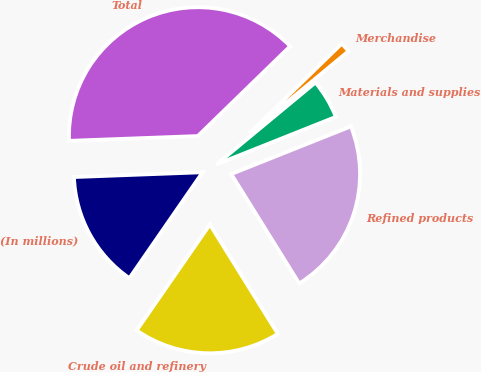<chart> <loc_0><loc_0><loc_500><loc_500><pie_chart><fcel>(In millions)<fcel>Crude oil and refinery<fcel>Refined products<fcel>Materials and supplies<fcel>Merchandise<fcel>Total<nl><fcel>14.78%<fcel>18.48%<fcel>22.19%<fcel>4.97%<fcel>1.27%<fcel>38.32%<nl></chart> 